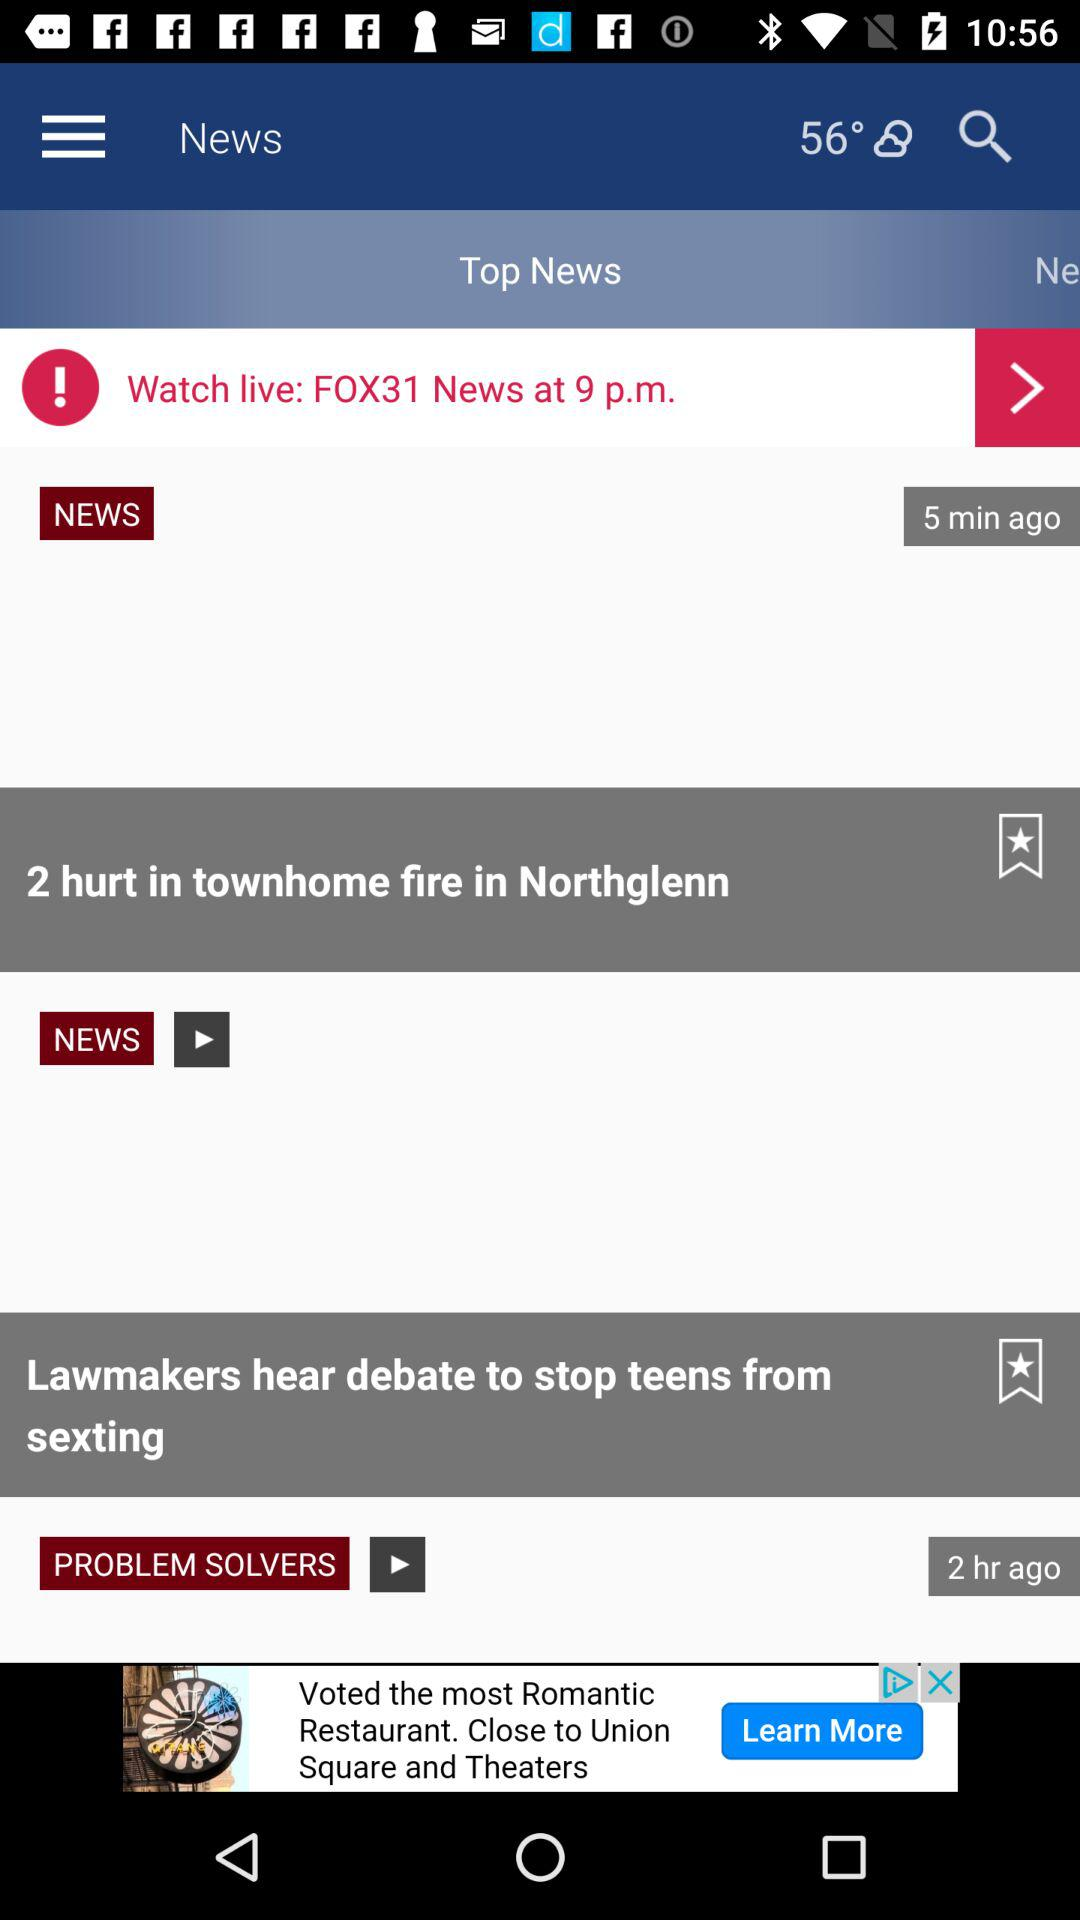What is the time to watch "FOX31 News"? The time to watch "FOX31 News" is 9 p.m. 